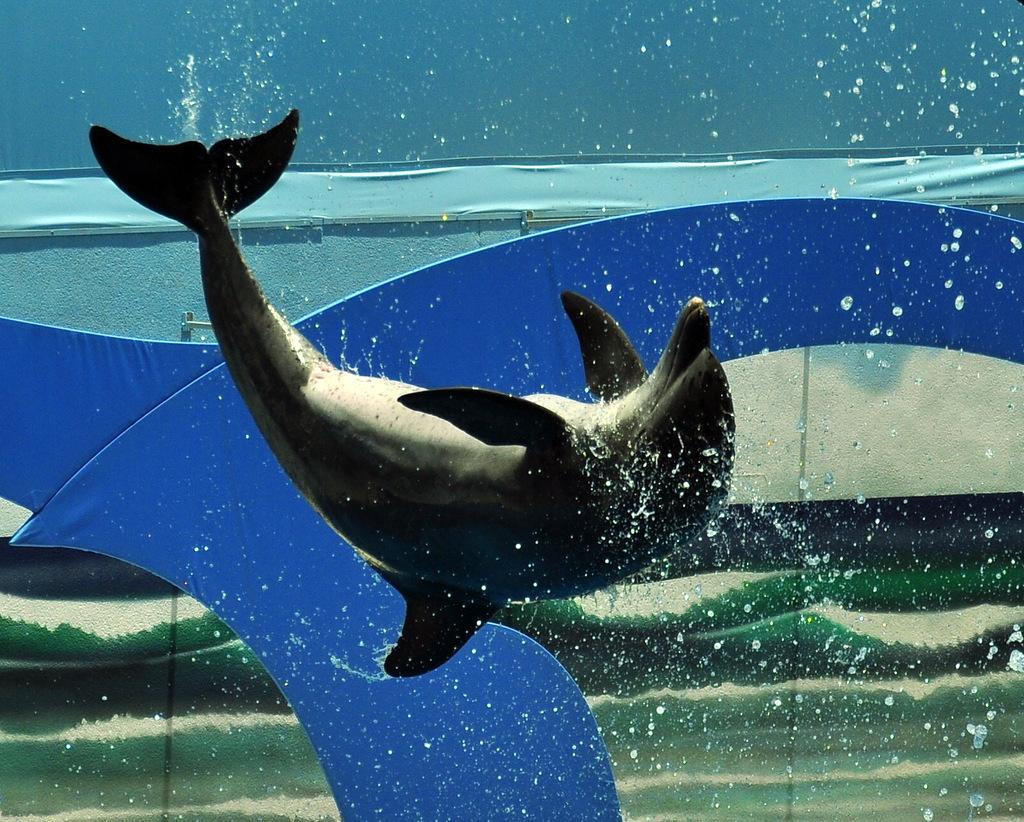Describe this image in one or two sentences. In this image there is a dolphin in the water. It seems like it is an art. 